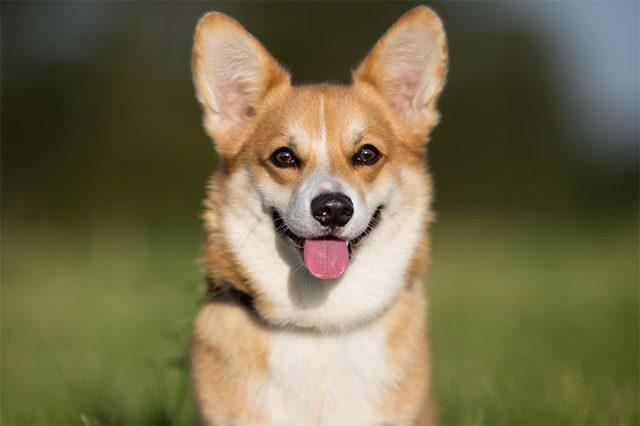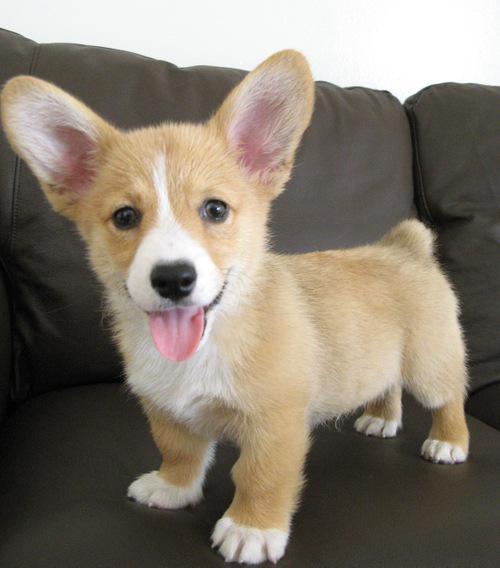The first image is the image on the left, the second image is the image on the right. Assess this claim about the two images: "A dog is walking on grass with one paw up.". Correct or not? Answer yes or no. No. The first image is the image on the left, the second image is the image on the right. Assess this claim about the two images: "the dog in the image on the left is in side profile". Correct or not? Answer yes or no. No. 